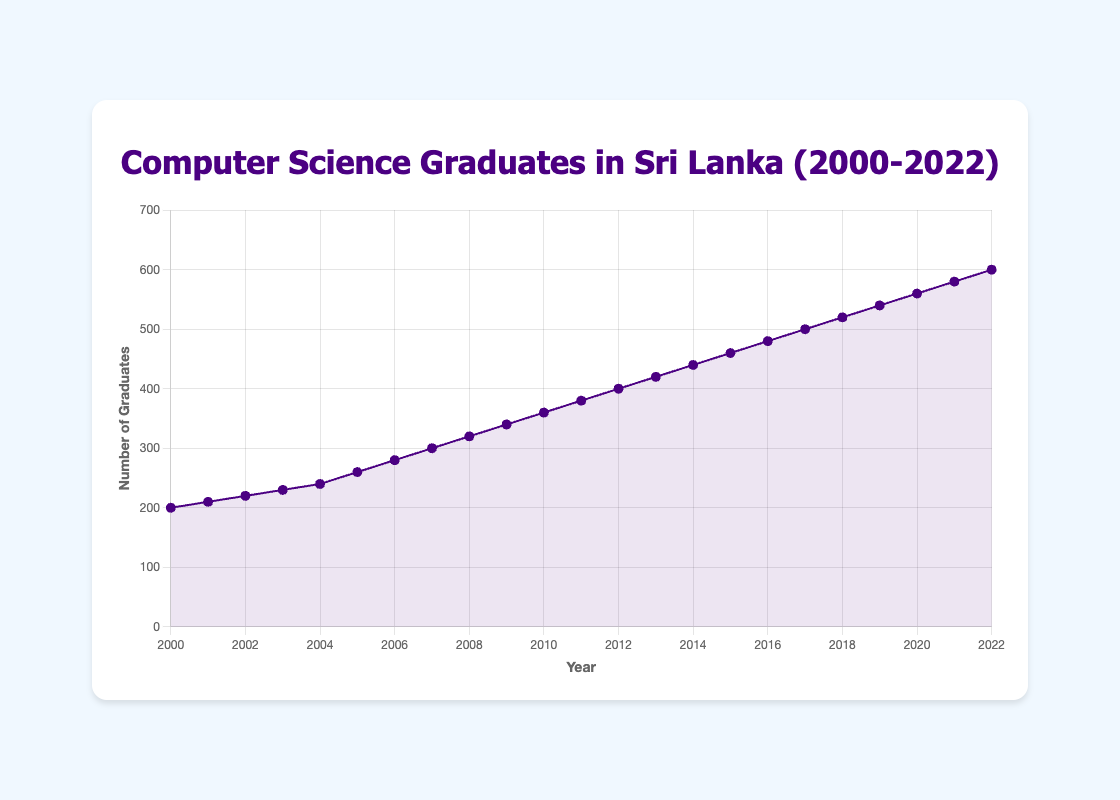Which year shows the smallest number of computer science graduates? The chart shows the number of graduates from 2000 to 2022. The smallest number of graduates can be identified by looking at the lowest point on the graph, which corresponds to the year 2000.
Answer: 2000 What is the trend in the number of computer science graduates from 2000 to 2022? Observing the plotted line, we can see that the number of graduates increases steadily from 2000 to 2022, representing a consistent upward trend.
Answer: Increasing In which year did the number of graduates first reach or exceed 400? On observing the graph, the first year where the number of graduates is equal to or greater than 400 is in 2012, where the number of graduates reaches exactly 400.
Answer: 2012 By how much did the number of computer science graduates increase between 2005 and 2015? To find the increase, subtract the number of graduates in 2005 from that in 2015. In 2005, there were 260 graduates, and in 2015, there were 460. The increase is 460 - 260 = 200 graduates.
Answer: 200 How many more graduates were there in 2022 compared to 2000? The number of graduates in 2022 is 600 and in 2000 it was 200. Subtracting these two values gives 600 - 200 = 400 more graduates in 2022 compared to 2000.
Answer: 400 What was the average annual increase in the number of graduates from 2000 to 2022? Calculate the difference in the number of graduates from 2000 to 2022, which is 600 - 200 = 400. Then divide by the number of years, which is 2022 - 2000 = 22 years. The average annual increase is 400 / 22 ≈ 18.18 graduates per year.
Answer: 18.18 Which years had the same number of graduates? Carefully observing the graph, there are no two years with the exact same number of graduates, as the number of graduates increases each year without repeating any value.
Answer: None Did the number of graduates ever decrease from one year to the next? By looking at the line chart, we see that the number of graduates consistently increases each year, with no decreases.
Answer: No What is the most significant increase in the number of computer science graduates in a single year? To find the largest single-year increase, compare the year-to-year differences. The largest difference is between consecutive years 2021 and 2022, where the number increased from 580 to 600, an increase of 20 graduates.
Answer: 20 How did the number of graduates change from 2010 to 2012? The number of graduates in 2010 was 360, and in 2012 it was 400. Subtract the earlier year's number from the later year's number: 400 - 360 = 40. The number increased by 40 graduates.
Answer: Increased by 40 